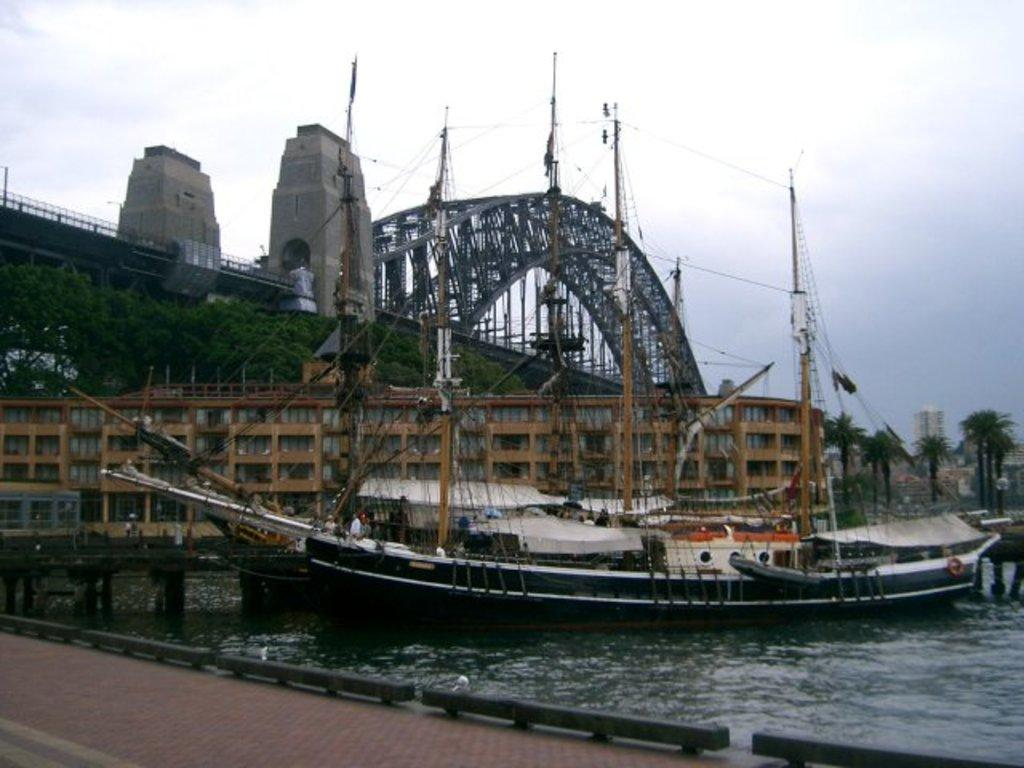What type of vehicles can be seen on the water in the image? There are boats on the water in the image. What type of structures are present in the image? There are buildings, a bridge, and towers in the image. What type of vegetation is present in the image? Trees are present in the image. What type of pathway is visible in the image? A sidewalk is visible in the image. What part of the natural environment is visible in the image? The sky is visible in the image. What type of bells can be heard ringing in the image? There are no bells present in the image, and therefore no sound can be heard. What type of wealth is depicted in the image? There is no depiction of wealth in the image; it features boats, buildings, trees, a bridge, a sidewalk, towers, and the sky. 